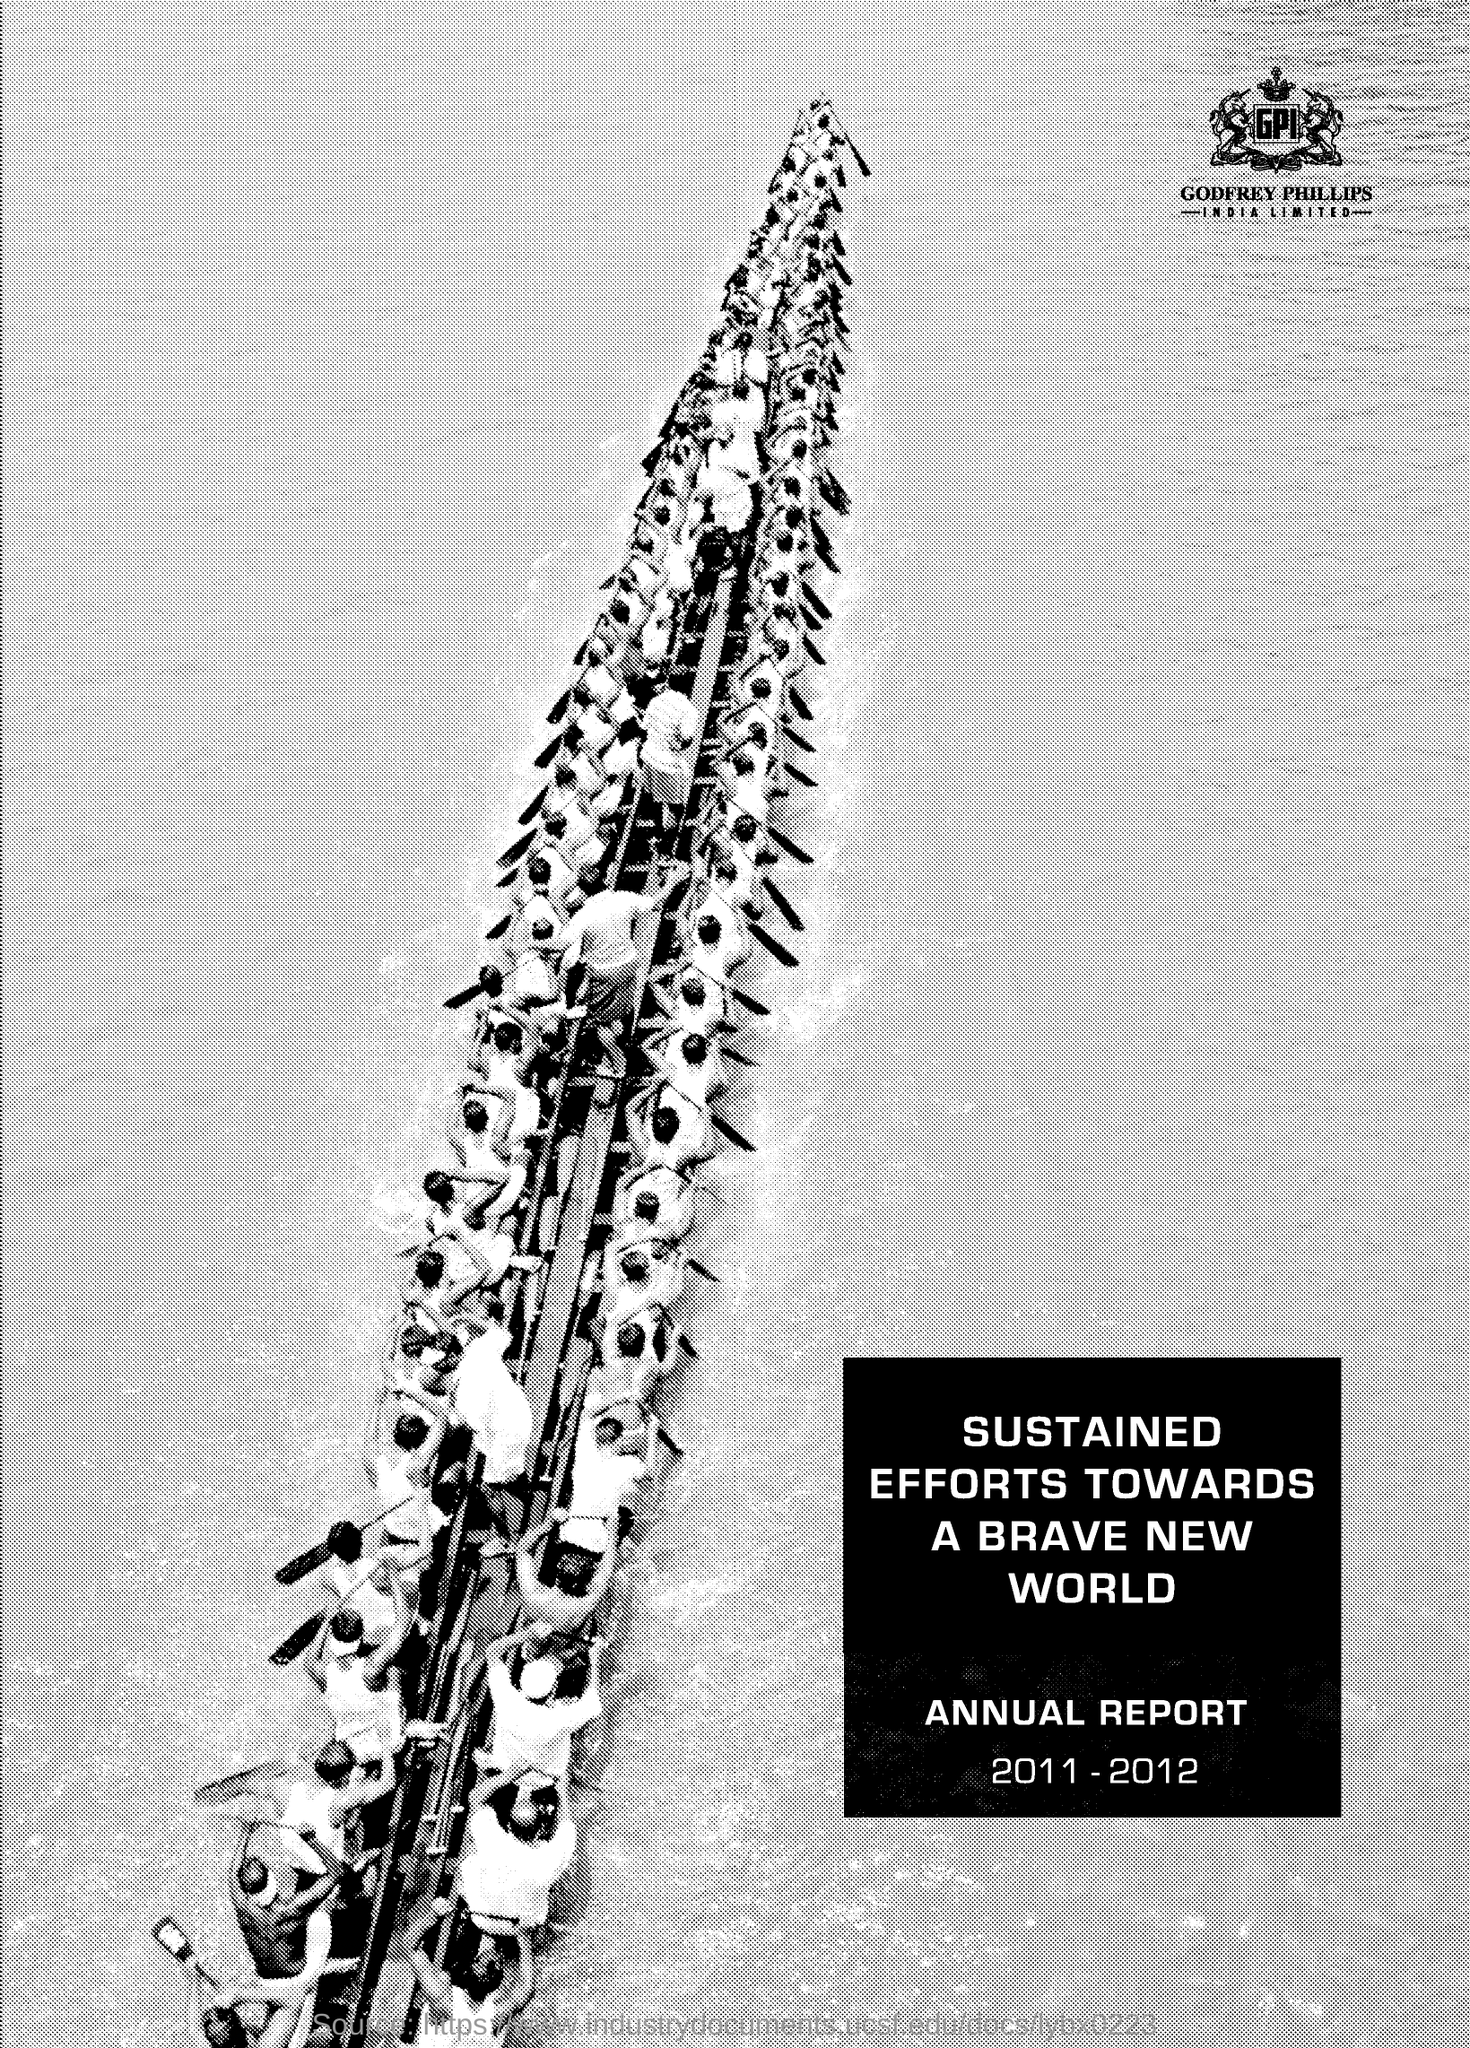Which company is mentioned in the document?
Your answer should be compact. GODFREY PHILLIPS INDIA LIMITED. In the annual report  which years are mentioned?
Your answer should be compact. 2011-2012. 